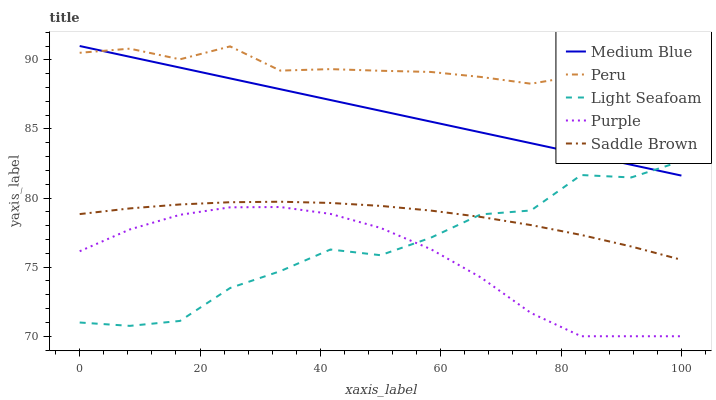Does Light Seafoam have the minimum area under the curve?
Answer yes or no. No. Does Light Seafoam have the maximum area under the curve?
Answer yes or no. No. Is Light Seafoam the smoothest?
Answer yes or no. No. Is Medium Blue the roughest?
Answer yes or no. No. Does Light Seafoam have the lowest value?
Answer yes or no. No. Does Light Seafoam have the highest value?
Answer yes or no. No. Is Saddle Brown less than Medium Blue?
Answer yes or no. Yes. Is Saddle Brown greater than Purple?
Answer yes or no. Yes. Does Saddle Brown intersect Medium Blue?
Answer yes or no. No. 